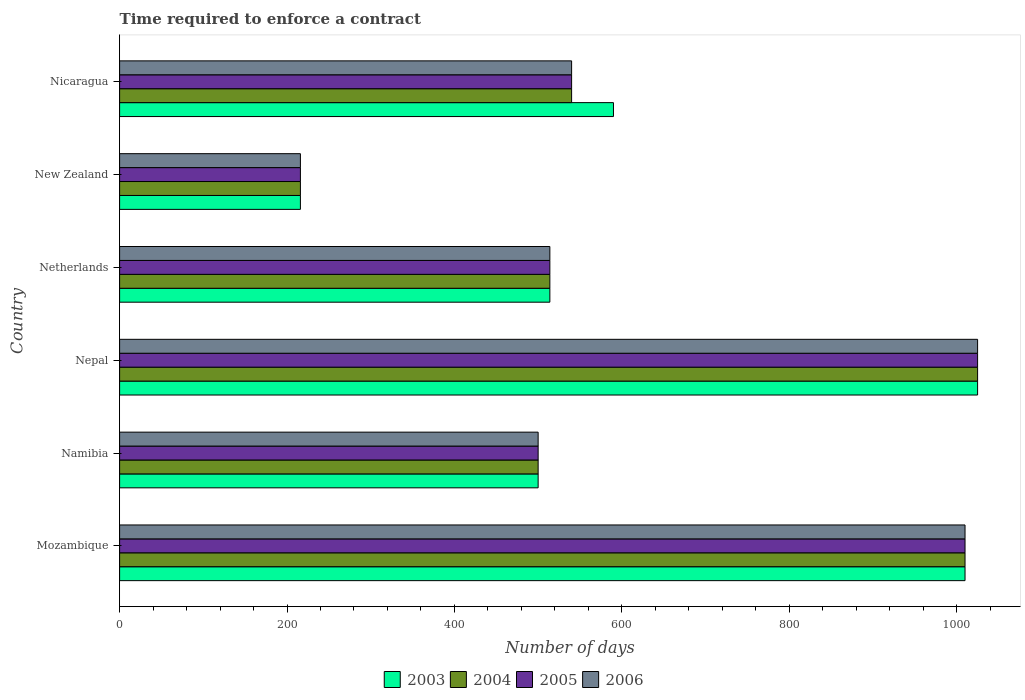How many groups of bars are there?
Provide a short and direct response. 6. Are the number of bars per tick equal to the number of legend labels?
Your answer should be very brief. Yes. Are the number of bars on each tick of the Y-axis equal?
Keep it short and to the point. Yes. How many bars are there on the 2nd tick from the top?
Provide a short and direct response. 4. How many bars are there on the 5th tick from the bottom?
Provide a succinct answer. 4. What is the label of the 3rd group of bars from the top?
Make the answer very short. Netherlands. What is the number of days required to enforce a contract in 2004 in Nicaragua?
Offer a very short reply. 540. Across all countries, what is the maximum number of days required to enforce a contract in 2004?
Provide a short and direct response. 1025. Across all countries, what is the minimum number of days required to enforce a contract in 2003?
Ensure brevity in your answer.  216. In which country was the number of days required to enforce a contract in 2006 maximum?
Offer a terse response. Nepal. In which country was the number of days required to enforce a contract in 2004 minimum?
Give a very brief answer. New Zealand. What is the total number of days required to enforce a contract in 2005 in the graph?
Provide a short and direct response. 3805. What is the difference between the number of days required to enforce a contract in 2006 in Nepal and that in Netherlands?
Ensure brevity in your answer.  511. What is the difference between the number of days required to enforce a contract in 2005 in Mozambique and the number of days required to enforce a contract in 2006 in Nicaragua?
Your response must be concise. 470. What is the average number of days required to enforce a contract in 2004 per country?
Your answer should be very brief. 634.17. What is the ratio of the number of days required to enforce a contract in 2004 in Nepal to that in Nicaragua?
Provide a succinct answer. 1.9. Is the difference between the number of days required to enforce a contract in 2005 in Mozambique and Nicaragua greater than the difference between the number of days required to enforce a contract in 2004 in Mozambique and Nicaragua?
Provide a succinct answer. No. What is the difference between the highest and the second highest number of days required to enforce a contract in 2006?
Offer a terse response. 15. What is the difference between the highest and the lowest number of days required to enforce a contract in 2004?
Provide a short and direct response. 809. What does the 4th bar from the top in Nicaragua represents?
Keep it short and to the point. 2003. What does the 4th bar from the bottom in Nicaragua represents?
Provide a succinct answer. 2006. Is it the case that in every country, the sum of the number of days required to enforce a contract in 2006 and number of days required to enforce a contract in 2005 is greater than the number of days required to enforce a contract in 2003?
Ensure brevity in your answer.  Yes. What is the difference between two consecutive major ticks on the X-axis?
Ensure brevity in your answer.  200. Does the graph contain any zero values?
Offer a terse response. No. Does the graph contain grids?
Your response must be concise. No. Where does the legend appear in the graph?
Provide a short and direct response. Bottom center. How many legend labels are there?
Keep it short and to the point. 4. How are the legend labels stacked?
Offer a very short reply. Horizontal. What is the title of the graph?
Ensure brevity in your answer.  Time required to enforce a contract. What is the label or title of the X-axis?
Ensure brevity in your answer.  Number of days. What is the Number of days in 2003 in Mozambique?
Ensure brevity in your answer.  1010. What is the Number of days of 2004 in Mozambique?
Your answer should be very brief. 1010. What is the Number of days of 2005 in Mozambique?
Your answer should be compact. 1010. What is the Number of days of 2006 in Mozambique?
Provide a short and direct response. 1010. What is the Number of days of 2005 in Namibia?
Ensure brevity in your answer.  500. What is the Number of days of 2006 in Namibia?
Give a very brief answer. 500. What is the Number of days in 2003 in Nepal?
Give a very brief answer. 1025. What is the Number of days in 2004 in Nepal?
Provide a succinct answer. 1025. What is the Number of days in 2005 in Nepal?
Your answer should be compact. 1025. What is the Number of days of 2006 in Nepal?
Provide a short and direct response. 1025. What is the Number of days in 2003 in Netherlands?
Provide a succinct answer. 514. What is the Number of days in 2004 in Netherlands?
Keep it short and to the point. 514. What is the Number of days in 2005 in Netherlands?
Give a very brief answer. 514. What is the Number of days of 2006 in Netherlands?
Offer a terse response. 514. What is the Number of days of 2003 in New Zealand?
Provide a succinct answer. 216. What is the Number of days in 2004 in New Zealand?
Make the answer very short. 216. What is the Number of days of 2005 in New Zealand?
Your answer should be compact. 216. What is the Number of days in 2006 in New Zealand?
Ensure brevity in your answer.  216. What is the Number of days in 2003 in Nicaragua?
Your answer should be compact. 590. What is the Number of days of 2004 in Nicaragua?
Give a very brief answer. 540. What is the Number of days in 2005 in Nicaragua?
Provide a short and direct response. 540. What is the Number of days in 2006 in Nicaragua?
Provide a short and direct response. 540. Across all countries, what is the maximum Number of days in 2003?
Ensure brevity in your answer.  1025. Across all countries, what is the maximum Number of days in 2004?
Offer a very short reply. 1025. Across all countries, what is the maximum Number of days of 2005?
Ensure brevity in your answer.  1025. Across all countries, what is the maximum Number of days of 2006?
Provide a succinct answer. 1025. Across all countries, what is the minimum Number of days in 2003?
Provide a succinct answer. 216. Across all countries, what is the minimum Number of days of 2004?
Provide a short and direct response. 216. Across all countries, what is the minimum Number of days in 2005?
Make the answer very short. 216. Across all countries, what is the minimum Number of days of 2006?
Offer a terse response. 216. What is the total Number of days in 2003 in the graph?
Ensure brevity in your answer.  3855. What is the total Number of days in 2004 in the graph?
Offer a terse response. 3805. What is the total Number of days in 2005 in the graph?
Your response must be concise. 3805. What is the total Number of days in 2006 in the graph?
Provide a short and direct response. 3805. What is the difference between the Number of days of 2003 in Mozambique and that in Namibia?
Provide a short and direct response. 510. What is the difference between the Number of days in 2004 in Mozambique and that in Namibia?
Keep it short and to the point. 510. What is the difference between the Number of days of 2005 in Mozambique and that in Namibia?
Offer a very short reply. 510. What is the difference between the Number of days of 2006 in Mozambique and that in Namibia?
Your answer should be very brief. 510. What is the difference between the Number of days of 2005 in Mozambique and that in Nepal?
Your response must be concise. -15. What is the difference between the Number of days in 2006 in Mozambique and that in Nepal?
Offer a very short reply. -15. What is the difference between the Number of days in 2003 in Mozambique and that in Netherlands?
Keep it short and to the point. 496. What is the difference between the Number of days in 2004 in Mozambique and that in Netherlands?
Keep it short and to the point. 496. What is the difference between the Number of days in 2005 in Mozambique and that in Netherlands?
Make the answer very short. 496. What is the difference between the Number of days in 2006 in Mozambique and that in Netherlands?
Offer a very short reply. 496. What is the difference between the Number of days of 2003 in Mozambique and that in New Zealand?
Make the answer very short. 794. What is the difference between the Number of days in 2004 in Mozambique and that in New Zealand?
Give a very brief answer. 794. What is the difference between the Number of days of 2005 in Mozambique and that in New Zealand?
Make the answer very short. 794. What is the difference between the Number of days of 2006 in Mozambique and that in New Zealand?
Your answer should be very brief. 794. What is the difference between the Number of days in 2003 in Mozambique and that in Nicaragua?
Provide a short and direct response. 420. What is the difference between the Number of days in 2004 in Mozambique and that in Nicaragua?
Provide a succinct answer. 470. What is the difference between the Number of days in 2005 in Mozambique and that in Nicaragua?
Offer a very short reply. 470. What is the difference between the Number of days in 2006 in Mozambique and that in Nicaragua?
Offer a very short reply. 470. What is the difference between the Number of days of 2003 in Namibia and that in Nepal?
Offer a very short reply. -525. What is the difference between the Number of days in 2004 in Namibia and that in Nepal?
Offer a terse response. -525. What is the difference between the Number of days in 2005 in Namibia and that in Nepal?
Your response must be concise. -525. What is the difference between the Number of days of 2006 in Namibia and that in Nepal?
Keep it short and to the point. -525. What is the difference between the Number of days in 2004 in Namibia and that in Netherlands?
Your answer should be compact. -14. What is the difference between the Number of days of 2003 in Namibia and that in New Zealand?
Keep it short and to the point. 284. What is the difference between the Number of days in 2004 in Namibia and that in New Zealand?
Keep it short and to the point. 284. What is the difference between the Number of days in 2005 in Namibia and that in New Zealand?
Your answer should be compact. 284. What is the difference between the Number of days in 2006 in Namibia and that in New Zealand?
Provide a short and direct response. 284. What is the difference between the Number of days of 2003 in Namibia and that in Nicaragua?
Your answer should be compact. -90. What is the difference between the Number of days of 2004 in Namibia and that in Nicaragua?
Keep it short and to the point. -40. What is the difference between the Number of days in 2006 in Namibia and that in Nicaragua?
Ensure brevity in your answer.  -40. What is the difference between the Number of days in 2003 in Nepal and that in Netherlands?
Your answer should be compact. 511. What is the difference between the Number of days of 2004 in Nepal and that in Netherlands?
Your answer should be compact. 511. What is the difference between the Number of days of 2005 in Nepal and that in Netherlands?
Your response must be concise. 511. What is the difference between the Number of days of 2006 in Nepal and that in Netherlands?
Provide a short and direct response. 511. What is the difference between the Number of days of 2003 in Nepal and that in New Zealand?
Offer a terse response. 809. What is the difference between the Number of days in 2004 in Nepal and that in New Zealand?
Your answer should be compact. 809. What is the difference between the Number of days in 2005 in Nepal and that in New Zealand?
Ensure brevity in your answer.  809. What is the difference between the Number of days of 2006 in Nepal and that in New Zealand?
Offer a very short reply. 809. What is the difference between the Number of days of 2003 in Nepal and that in Nicaragua?
Ensure brevity in your answer.  435. What is the difference between the Number of days in 2004 in Nepal and that in Nicaragua?
Your answer should be very brief. 485. What is the difference between the Number of days in 2005 in Nepal and that in Nicaragua?
Your response must be concise. 485. What is the difference between the Number of days of 2006 in Nepal and that in Nicaragua?
Give a very brief answer. 485. What is the difference between the Number of days in 2003 in Netherlands and that in New Zealand?
Your response must be concise. 298. What is the difference between the Number of days in 2004 in Netherlands and that in New Zealand?
Keep it short and to the point. 298. What is the difference between the Number of days of 2005 in Netherlands and that in New Zealand?
Offer a very short reply. 298. What is the difference between the Number of days in 2006 in Netherlands and that in New Zealand?
Give a very brief answer. 298. What is the difference between the Number of days of 2003 in Netherlands and that in Nicaragua?
Your response must be concise. -76. What is the difference between the Number of days of 2005 in Netherlands and that in Nicaragua?
Your answer should be compact. -26. What is the difference between the Number of days in 2006 in Netherlands and that in Nicaragua?
Your response must be concise. -26. What is the difference between the Number of days of 2003 in New Zealand and that in Nicaragua?
Make the answer very short. -374. What is the difference between the Number of days of 2004 in New Zealand and that in Nicaragua?
Offer a very short reply. -324. What is the difference between the Number of days of 2005 in New Zealand and that in Nicaragua?
Offer a very short reply. -324. What is the difference between the Number of days of 2006 in New Zealand and that in Nicaragua?
Make the answer very short. -324. What is the difference between the Number of days of 2003 in Mozambique and the Number of days of 2004 in Namibia?
Offer a terse response. 510. What is the difference between the Number of days in 2003 in Mozambique and the Number of days in 2005 in Namibia?
Keep it short and to the point. 510. What is the difference between the Number of days in 2003 in Mozambique and the Number of days in 2006 in Namibia?
Your response must be concise. 510. What is the difference between the Number of days of 2004 in Mozambique and the Number of days of 2005 in Namibia?
Make the answer very short. 510. What is the difference between the Number of days in 2004 in Mozambique and the Number of days in 2006 in Namibia?
Offer a terse response. 510. What is the difference between the Number of days in 2005 in Mozambique and the Number of days in 2006 in Namibia?
Offer a very short reply. 510. What is the difference between the Number of days of 2003 in Mozambique and the Number of days of 2005 in Nepal?
Ensure brevity in your answer.  -15. What is the difference between the Number of days of 2003 in Mozambique and the Number of days of 2006 in Nepal?
Provide a succinct answer. -15. What is the difference between the Number of days in 2005 in Mozambique and the Number of days in 2006 in Nepal?
Ensure brevity in your answer.  -15. What is the difference between the Number of days of 2003 in Mozambique and the Number of days of 2004 in Netherlands?
Give a very brief answer. 496. What is the difference between the Number of days of 2003 in Mozambique and the Number of days of 2005 in Netherlands?
Ensure brevity in your answer.  496. What is the difference between the Number of days of 2003 in Mozambique and the Number of days of 2006 in Netherlands?
Provide a succinct answer. 496. What is the difference between the Number of days in 2004 in Mozambique and the Number of days in 2005 in Netherlands?
Provide a succinct answer. 496. What is the difference between the Number of days in 2004 in Mozambique and the Number of days in 2006 in Netherlands?
Give a very brief answer. 496. What is the difference between the Number of days of 2005 in Mozambique and the Number of days of 2006 in Netherlands?
Provide a succinct answer. 496. What is the difference between the Number of days of 2003 in Mozambique and the Number of days of 2004 in New Zealand?
Offer a very short reply. 794. What is the difference between the Number of days of 2003 in Mozambique and the Number of days of 2005 in New Zealand?
Your response must be concise. 794. What is the difference between the Number of days in 2003 in Mozambique and the Number of days in 2006 in New Zealand?
Give a very brief answer. 794. What is the difference between the Number of days of 2004 in Mozambique and the Number of days of 2005 in New Zealand?
Your answer should be compact. 794. What is the difference between the Number of days of 2004 in Mozambique and the Number of days of 2006 in New Zealand?
Keep it short and to the point. 794. What is the difference between the Number of days in 2005 in Mozambique and the Number of days in 2006 in New Zealand?
Provide a short and direct response. 794. What is the difference between the Number of days of 2003 in Mozambique and the Number of days of 2004 in Nicaragua?
Your response must be concise. 470. What is the difference between the Number of days in 2003 in Mozambique and the Number of days in 2005 in Nicaragua?
Offer a terse response. 470. What is the difference between the Number of days of 2003 in Mozambique and the Number of days of 2006 in Nicaragua?
Your response must be concise. 470. What is the difference between the Number of days in 2004 in Mozambique and the Number of days in 2005 in Nicaragua?
Offer a very short reply. 470. What is the difference between the Number of days in 2004 in Mozambique and the Number of days in 2006 in Nicaragua?
Offer a very short reply. 470. What is the difference between the Number of days of 2005 in Mozambique and the Number of days of 2006 in Nicaragua?
Give a very brief answer. 470. What is the difference between the Number of days of 2003 in Namibia and the Number of days of 2004 in Nepal?
Your response must be concise. -525. What is the difference between the Number of days in 2003 in Namibia and the Number of days in 2005 in Nepal?
Your answer should be compact. -525. What is the difference between the Number of days of 2003 in Namibia and the Number of days of 2006 in Nepal?
Give a very brief answer. -525. What is the difference between the Number of days in 2004 in Namibia and the Number of days in 2005 in Nepal?
Offer a very short reply. -525. What is the difference between the Number of days of 2004 in Namibia and the Number of days of 2006 in Nepal?
Keep it short and to the point. -525. What is the difference between the Number of days in 2005 in Namibia and the Number of days in 2006 in Nepal?
Offer a terse response. -525. What is the difference between the Number of days in 2003 in Namibia and the Number of days in 2005 in Netherlands?
Provide a succinct answer. -14. What is the difference between the Number of days of 2004 in Namibia and the Number of days of 2005 in Netherlands?
Give a very brief answer. -14. What is the difference between the Number of days of 2003 in Namibia and the Number of days of 2004 in New Zealand?
Make the answer very short. 284. What is the difference between the Number of days of 2003 in Namibia and the Number of days of 2005 in New Zealand?
Make the answer very short. 284. What is the difference between the Number of days in 2003 in Namibia and the Number of days in 2006 in New Zealand?
Provide a short and direct response. 284. What is the difference between the Number of days of 2004 in Namibia and the Number of days of 2005 in New Zealand?
Your answer should be compact. 284. What is the difference between the Number of days in 2004 in Namibia and the Number of days in 2006 in New Zealand?
Ensure brevity in your answer.  284. What is the difference between the Number of days of 2005 in Namibia and the Number of days of 2006 in New Zealand?
Give a very brief answer. 284. What is the difference between the Number of days in 2003 in Namibia and the Number of days in 2006 in Nicaragua?
Your answer should be compact. -40. What is the difference between the Number of days in 2004 in Namibia and the Number of days in 2005 in Nicaragua?
Ensure brevity in your answer.  -40. What is the difference between the Number of days in 2003 in Nepal and the Number of days in 2004 in Netherlands?
Ensure brevity in your answer.  511. What is the difference between the Number of days in 2003 in Nepal and the Number of days in 2005 in Netherlands?
Provide a succinct answer. 511. What is the difference between the Number of days in 2003 in Nepal and the Number of days in 2006 in Netherlands?
Ensure brevity in your answer.  511. What is the difference between the Number of days of 2004 in Nepal and the Number of days of 2005 in Netherlands?
Your answer should be very brief. 511. What is the difference between the Number of days of 2004 in Nepal and the Number of days of 2006 in Netherlands?
Your answer should be compact. 511. What is the difference between the Number of days of 2005 in Nepal and the Number of days of 2006 in Netherlands?
Keep it short and to the point. 511. What is the difference between the Number of days of 2003 in Nepal and the Number of days of 2004 in New Zealand?
Offer a very short reply. 809. What is the difference between the Number of days of 2003 in Nepal and the Number of days of 2005 in New Zealand?
Provide a succinct answer. 809. What is the difference between the Number of days in 2003 in Nepal and the Number of days in 2006 in New Zealand?
Ensure brevity in your answer.  809. What is the difference between the Number of days of 2004 in Nepal and the Number of days of 2005 in New Zealand?
Make the answer very short. 809. What is the difference between the Number of days in 2004 in Nepal and the Number of days in 2006 in New Zealand?
Your answer should be compact. 809. What is the difference between the Number of days of 2005 in Nepal and the Number of days of 2006 in New Zealand?
Offer a very short reply. 809. What is the difference between the Number of days of 2003 in Nepal and the Number of days of 2004 in Nicaragua?
Provide a succinct answer. 485. What is the difference between the Number of days in 2003 in Nepal and the Number of days in 2005 in Nicaragua?
Ensure brevity in your answer.  485. What is the difference between the Number of days in 2003 in Nepal and the Number of days in 2006 in Nicaragua?
Your response must be concise. 485. What is the difference between the Number of days of 2004 in Nepal and the Number of days of 2005 in Nicaragua?
Your answer should be compact. 485. What is the difference between the Number of days of 2004 in Nepal and the Number of days of 2006 in Nicaragua?
Give a very brief answer. 485. What is the difference between the Number of days in 2005 in Nepal and the Number of days in 2006 in Nicaragua?
Your response must be concise. 485. What is the difference between the Number of days of 2003 in Netherlands and the Number of days of 2004 in New Zealand?
Ensure brevity in your answer.  298. What is the difference between the Number of days in 2003 in Netherlands and the Number of days in 2005 in New Zealand?
Make the answer very short. 298. What is the difference between the Number of days of 2003 in Netherlands and the Number of days of 2006 in New Zealand?
Your answer should be compact. 298. What is the difference between the Number of days of 2004 in Netherlands and the Number of days of 2005 in New Zealand?
Your response must be concise. 298. What is the difference between the Number of days in 2004 in Netherlands and the Number of days in 2006 in New Zealand?
Your answer should be compact. 298. What is the difference between the Number of days in 2005 in Netherlands and the Number of days in 2006 in New Zealand?
Make the answer very short. 298. What is the difference between the Number of days of 2003 in Netherlands and the Number of days of 2005 in Nicaragua?
Make the answer very short. -26. What is the difference between the Number of days in 2003 in Netherlands and the Number of days in 2006 in Nicaragua?
Your response must be concise. -26. What is the difference between the Number of days in 2005 in Netherlands and the Number of days in 2006 in Nicaragua?
Your answer should be compact. -26. What is the difference between the Number of days of 2003 in New Zealand and the Number of days of 2004 in Nicaragua?
Offer a very short reply. -324. What is the difference between the Number of days in 2003 in New Zealand and the Number of days in 2005 in Nicaragua?
Make the answer very short. -324. What is the difference between the Number of days in 2003 in New Zealand and the Number of days in 2006 in Nicaragua?
Make the answer very short. -324. What is the difference between the Number of days in 2004 in New Zealand and the Number of days in 2005 in Nicaragua?
Provide a short and direct response. -324. What is the difference between the Number of days of 2004 in New Zealand and the Number of days of 2006 in Nicaragua?
Ensure brevity in your answer.  -324. What is the difference between the Number of days in 2005 in New Zealand and the Number of days in 2006 in Nicaragua?
Your answer should be very brief. -324. What is the average Number of days in 2003 per country?
Provide a succinct answer. 642.5. What is the average Number of days in 2004 per country?
Provide a short and direct response. 634.17. What is the average Number of days of 2005 per country?
Offer a very short reply. 634.17. What is the average Number of days of 2006 per country?
Keep it short and to the point. 634.17. What is the difference between the Number of days of 2003 and Number of days of 2005 in Mozambique?
Ensure brevity in your answer.  0. What is the difference between the Number of days of 2003 and Number of days of 2004 in Namibia?
Make the answer very short. 0. What is the difference between the Number of days of 2003 and Number of days of 2005 in Namibia?
Keep it short and to the point. 0. What is the difference between the Number of days in 2003 and Number of days in 2006 in Namibia?
Your answer should be very brief. 0. What is the difference between the Number of days of 2004 and Number of days of 2005 in Namibia?
Keep it short and to the point. 0. What is the difference between the Number of days in 2004 and Number of days in 2006 in Namibia?
Keep it short and to the point. 0. What is the difference between the Number of days in 2005 and Number of days in 2006 in Namibia?
Your answer should be compact. 0. What is the difference between the Number of days of 2003 and Number of days of 2006 in Nepal?
Keep it short and to the point. 0. What is the difference between the Number of days of 2005 and Number of days of 2006 in Nepal?
Your answer should be compact. 0. What is the difference between the Number of days of 2004 and Number of days of 2006 in Netherlands?
Your response must be concise. 0. What is the difference between the Number of days in 2003 and Number of days in 2005 in New Zealand?
Give a very brief answer. 0. What is the difference between the Number of days of 2004 and Number of days of 2005 in New Zealand?
Your response must be concise. 0. What is the difference between the Number of days of 2005 and Number of days of 2006 in New Zealand?
Your answer should be very brief. 0. What is the difference between the Number of days of 2003 and Number of days of 2005 in Nicaragua?
Your response must be concise. 50. What is the difference between the Number of days of 2003 and Number of days of 2006 in Nicaragua?
Your answer should be compact. 50. What is the ratio of the Number of days in 2003 in Mozambique to that in Namibia?
Make the answer very short. 2.02. What is the ratio of the Number of days in 2004 in Mozambique to that in Namibia?
Make the answer very short. 2.02. What is the ratio of the Number of days in 2005 in Mozambique to that in Namibia?
Make the answer very short. 2.02. What is the ratio of the Number of days of 2006 in Mozambique to that in Namibia?
Offer a very short reply. 2.02. What is the ratio of the Number of days of 2003 in Mozambique to that in Nepal?
Offer a terse response. 0.99. What is the ratio of the Number of days in 2004 in Mozambique to that in Nepal?
Offer a terse response. 0.99. What is the ratio of the Number of days of 2005 in Mozambique to that in Nepal?
Give a very brief answer. 0.99. What is the ratio of the Number of days in 2006 in Mozambique to that in Nepal?
Your response must be concise. 0.99. What is the ratio of the Number of days in 2003 in Mozambique to that in Netherlands?
Your answer should be very brief. 1.97. What is the ratio of the Number of days in 2004 in Mozambique to that in Netherlands?
Give a very brief answer. 1.97. What is the ratio of the Number of days in 2005 in Mozambique to that in Netherlands?
Ensure brevity in your answer.  1.97. What is the ratio of the Number of days in 2006 in Mozambique to that in Netherlands?
Your answer should be compact. 1.97. What is the ratio of the Number of days of 2003 in Mozambique to that in New Zealand?
Keep it short and to the point. 4.68. What is the ratio of the Number of days in 2004 in Mozambique to that in New Zealand?
Ensure brevity in your answer.  4.68. What is the ratio of the Number of days of 2005 in Mozambique to that in New Zealand?
Offer a terse response. 4.68. What is the ratio of the Number of days of 2006 in Mozambique to that in New Zealand?
Your response must be concise. 4.68. What is the ratio of the Number of days in 2003 in Mozambique to that in Nicaragua?
Ensure brevity in your answer.  1.71. What is the ratio of the Number of days in 2004 in Mozambique to that in Nicaragua?
Make the answer very short. 1.87. What is the ratio of the Number of days of 2005 in Mozambique to that in Nicaragua?
Provide a succinct answer. 1.87. What is the ratio of the Number of days in 2006 in Mozambique to that in Nicaragua?
Provide a short and direct response. 1.87. What is the ratio of the Number of days of 2003 in Namibia to that in Nepal?
Offer a terse response. 0.49. What is the ratio of the Number of days of 2004 in Namibia to that in Nepal?
Keep it short and to the point. 0.49. What is the ratio of the Number of days of 2005 in Namibia to that in Nepal?
Ensure brevity in your answer.  0.49. What is the ratio of the Number of days of 2006 in Namibia to that in Nepal?
Make the answer very short. 0.49. What is the ratio of the Number of days of 2003 in Namibia to that in Netherlands?
Give a very brief answer. 0.97. What is the ratio of the Number of days in 2004 in Namibia to that in Netherlands?
Your answer should be compact. 0.97. What is the ratio of the Number of days of 2005 in Namibia to that in Netherlands?
Provide a succinct answer. 0.97. What is the ratio of the Number of days in 2006 in Namibia to that in Netherlands?
Your answer should be very brief. 0.97. What is the ratio of the Number of days in 2003 in Namibia to that in New Zealand?
Provide a short and direct response. 2.31. What is the ratio of the Number of days in 2004 in Namibia to that in New Zealand?
Your response must be concise. 2.31. What is the ratio of the Number of days of 2005 in Namibia to that in New Zealand?
Provide a succinct answer. 2.31. What is the ratio of the Number of days of 2006 in Namibia to that in New Zealand?
Provide a succinct answer. 2.31. What is the ratio of the Number of days of 2003 in Namibia to that in Nicaragua?
Your answer should be very brief. 0.85. What is the ratio of the Number of days in 2004 in Namibia to that in Nicaragua?
Offer a terse response. 0.93. What is the ratio of the Number of days in 2005 in Namibia to that in Nicaragua?
Make the answer very short. 0.93. What is the ratio of the Number of days of 2006 in Namibia to that in Nicaragua?
Ensure brevity in your answer.  0.93. What is the ratio of the Number of days in 2003 in Nepal to that in Netherlands?
Make the answer very short. 1.99. What is the ratio of the Number of days in 2004 in Nepal to that in Netherlands?
Keep it short and to the point. 1.99. What is the ratio of the Number of days in 2005 in Nepal to that in Netherlands?
Your answer should be very brief. 1.99. What is the ratio of the Number of days in 2006 in Nepal to that in Netherlands?
Provide a short and direct response. 1.99. What is the ratio of the Number of days of 2003 in Nepal to that in New Zealand?
Your answer should be very brief. 4.75. What is the ratio of the Number of days in 2004 in Nepal to that in New Zealand?
Your answer should be very brief. 4.75. What is the ratio of the Number of days in 2005 in Nepal to that in New Zealand?
Offer a very short reply. 4.75. What is the ratio of the Number of days of 2006 in Nepal to that in New Zealand?
Your answer should be compact. 4.75. What is the ratio of the Number of days of 2003 in Nepal to that in Nicaragua?
Keep it short and to the point. 1.74. What is the ratio of the Number of days in 2004 in Nepal to that in Nicaragua?
Keep it short and to the point. 1.9. What is the ratio of the Number of days in 2005 in Nepal to that in Nicaragua?
Give a very brief answer. 1.9. What is the ratio of the Number of days in 2006 in Nepal to that in Nicaragua?
Provide a succinct answer. 1.9. What is the ratio of the Number of days in 2003 in Netherlands to that in New Zealand?
Provide a succinct answer. 2.38. What is the ratio of the Number of days of 2004 in Netherlands to that in New Zealand?
Offer a terse response. 2.38. What is the ratio of the Number of days of 2005 in Netherlands to that in New Zealand?
Your answer should be compact. 2.38. What is the ratio of the Number of days of 2006 in Netherlands to that in New Zealand?
Ensure brevity in your answer.  2.38. What is the ratio of the Number of days in 2003 in Netherlands to that in Nicaragua?
Your response must be concise. 0.87. What is the ratio of the Number of days of 2004 in Netherlands to that in Nicaragua?
Ensure brevity in your answer.  0.95. What is the ratio of the Number of days in 2005 in Netherlands to that in Nicaragua?
Your answer should be very brief. 0.95. What is the ratio of the Number of days of 2006 in Netherlands to that in Nicaragua?
Keep it short and to the point. 0.95. What is the ratio of the Number of days of 2003 in New Zealand to that in Nicaragua?
Your response must be concise. 0.37. What is the ratio of the Number of days of 2005 in New Zealand to that in Nicaragua?
Your response must be concise. 0.4. What is the difference between the highest and the second highest Number of days in 2006?
Make the answer very short. 15. What is the difference between the highest and the lowest Number of days of 2003?
Offer a terse response. 809. What is the difference between the highest and the lowest Number of days of 2004?
Your answer should be compact. 809. What is the difference between the highest and the lowest Number of days of 2005?
Your response must be concise. 809. What is the difference between the highest and the lowest Number of days in 2006?
Keep it short and to the point. 809. 